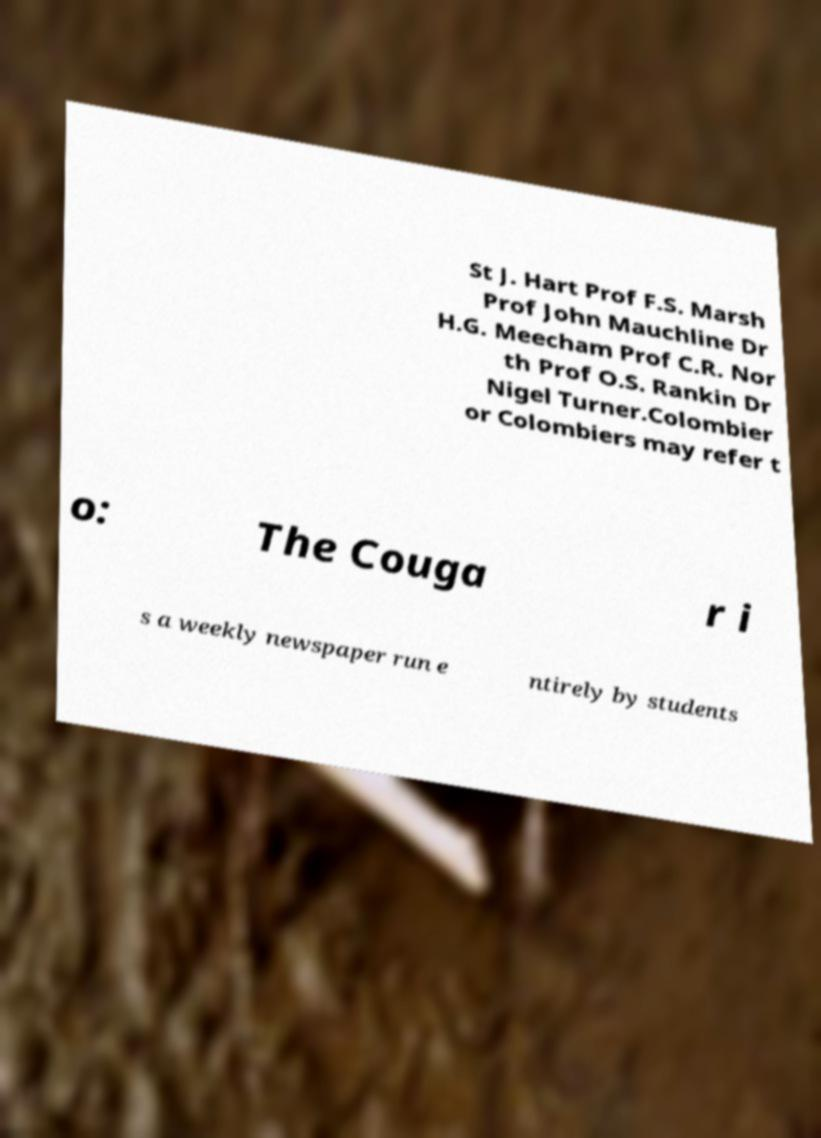Could you assist in decoding the text presented in this image and type it out clearly? St J. Hart Prof F.S. Marsh Prof John Mauchline Dr H.G. Meecham Prof C.R. Nor th Prof O.S. Rankin Dr Nigel Turner.Colombier or Colombiers may refer t o: The Couga r i s a weekly newspaper run e ntirely by students 